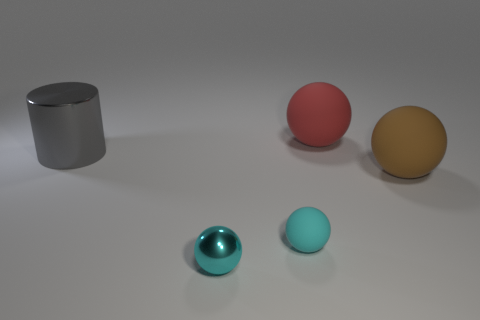Is there any other thing of the same color as the big metallic cylinder?
Your answer should be compact. No. Is the number of balls behind the small shiny thing less than the number of gray objects?
Offer a very short reply. No. Are there more big cyan metallic balls than gray shiny things?
Your answer should be compact. No. Are there any big gray things that are in front of the large matte sphere that is in front of the ball behind the big cylinder?
Your answer should be very brief. No. How many other things are there of the same size as the red object?
Ensure brevity in your answer.  2. Are there any gray shiny cylinders behind the small cyan rubber object?
Give a very brief answer. Yes. Do the shiny cylinder and the large rubber thing that is on the left side of the brown object have the same color?
Provide a succinct answer. No. There is a matte object that is in front of the big thing on the right side of the large rubber thing that is left of the big brown matte ball; what color is it?
Ensure brevity in your answer.  Cyan. Is there a tiny cyan thing that has the same shape as the big brown object?
Offer a very short reply. Yes. What is the color of the other sphere that is the same size as the red ball?
Offer a very short reply. Brown. 